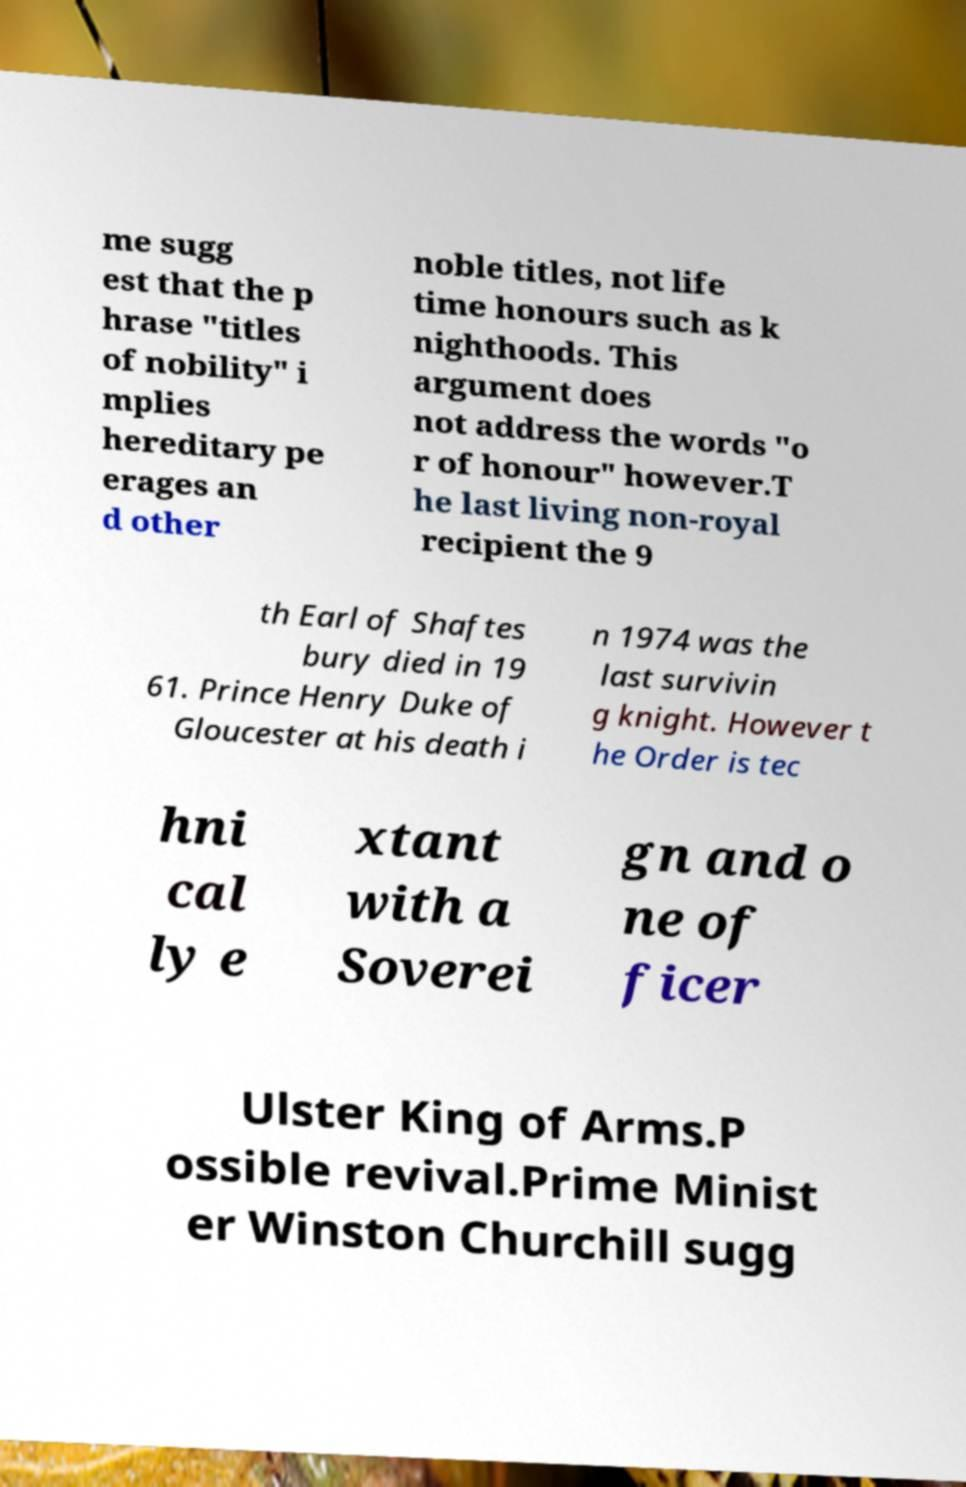What messages or text are displayed in this image? I need them in a readable, typed format. me sugg est that the p hrase "titles of nobility" i mplies hereditary pe erages an d other noble titles, not life time honours such as k nighthoods. This argument does not address the words "o r of honour" however.T he last living non-royal recipient the 9 th Earl of Shaftes bury died in 19 61. Prince Henry Duke of Gloucester at his death i n 1974 was the last survivin g knight. However t he Order is tec hni cal ly e xtant with a Soverei gn and o ne of ficer Ulster King of Arms.P ossible revival.Prime Minist er Winston Churchill sugg 